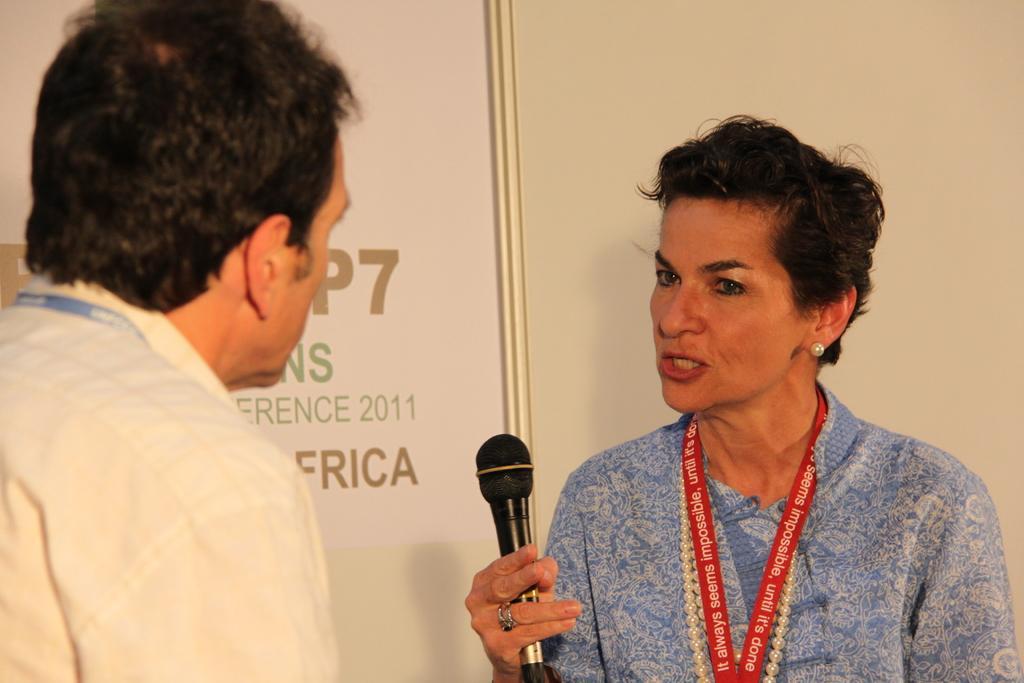Can you describe this image briefly? In this image I can see two people with different color dresses. I can see one person with the mic. In the background I can see the banner. 